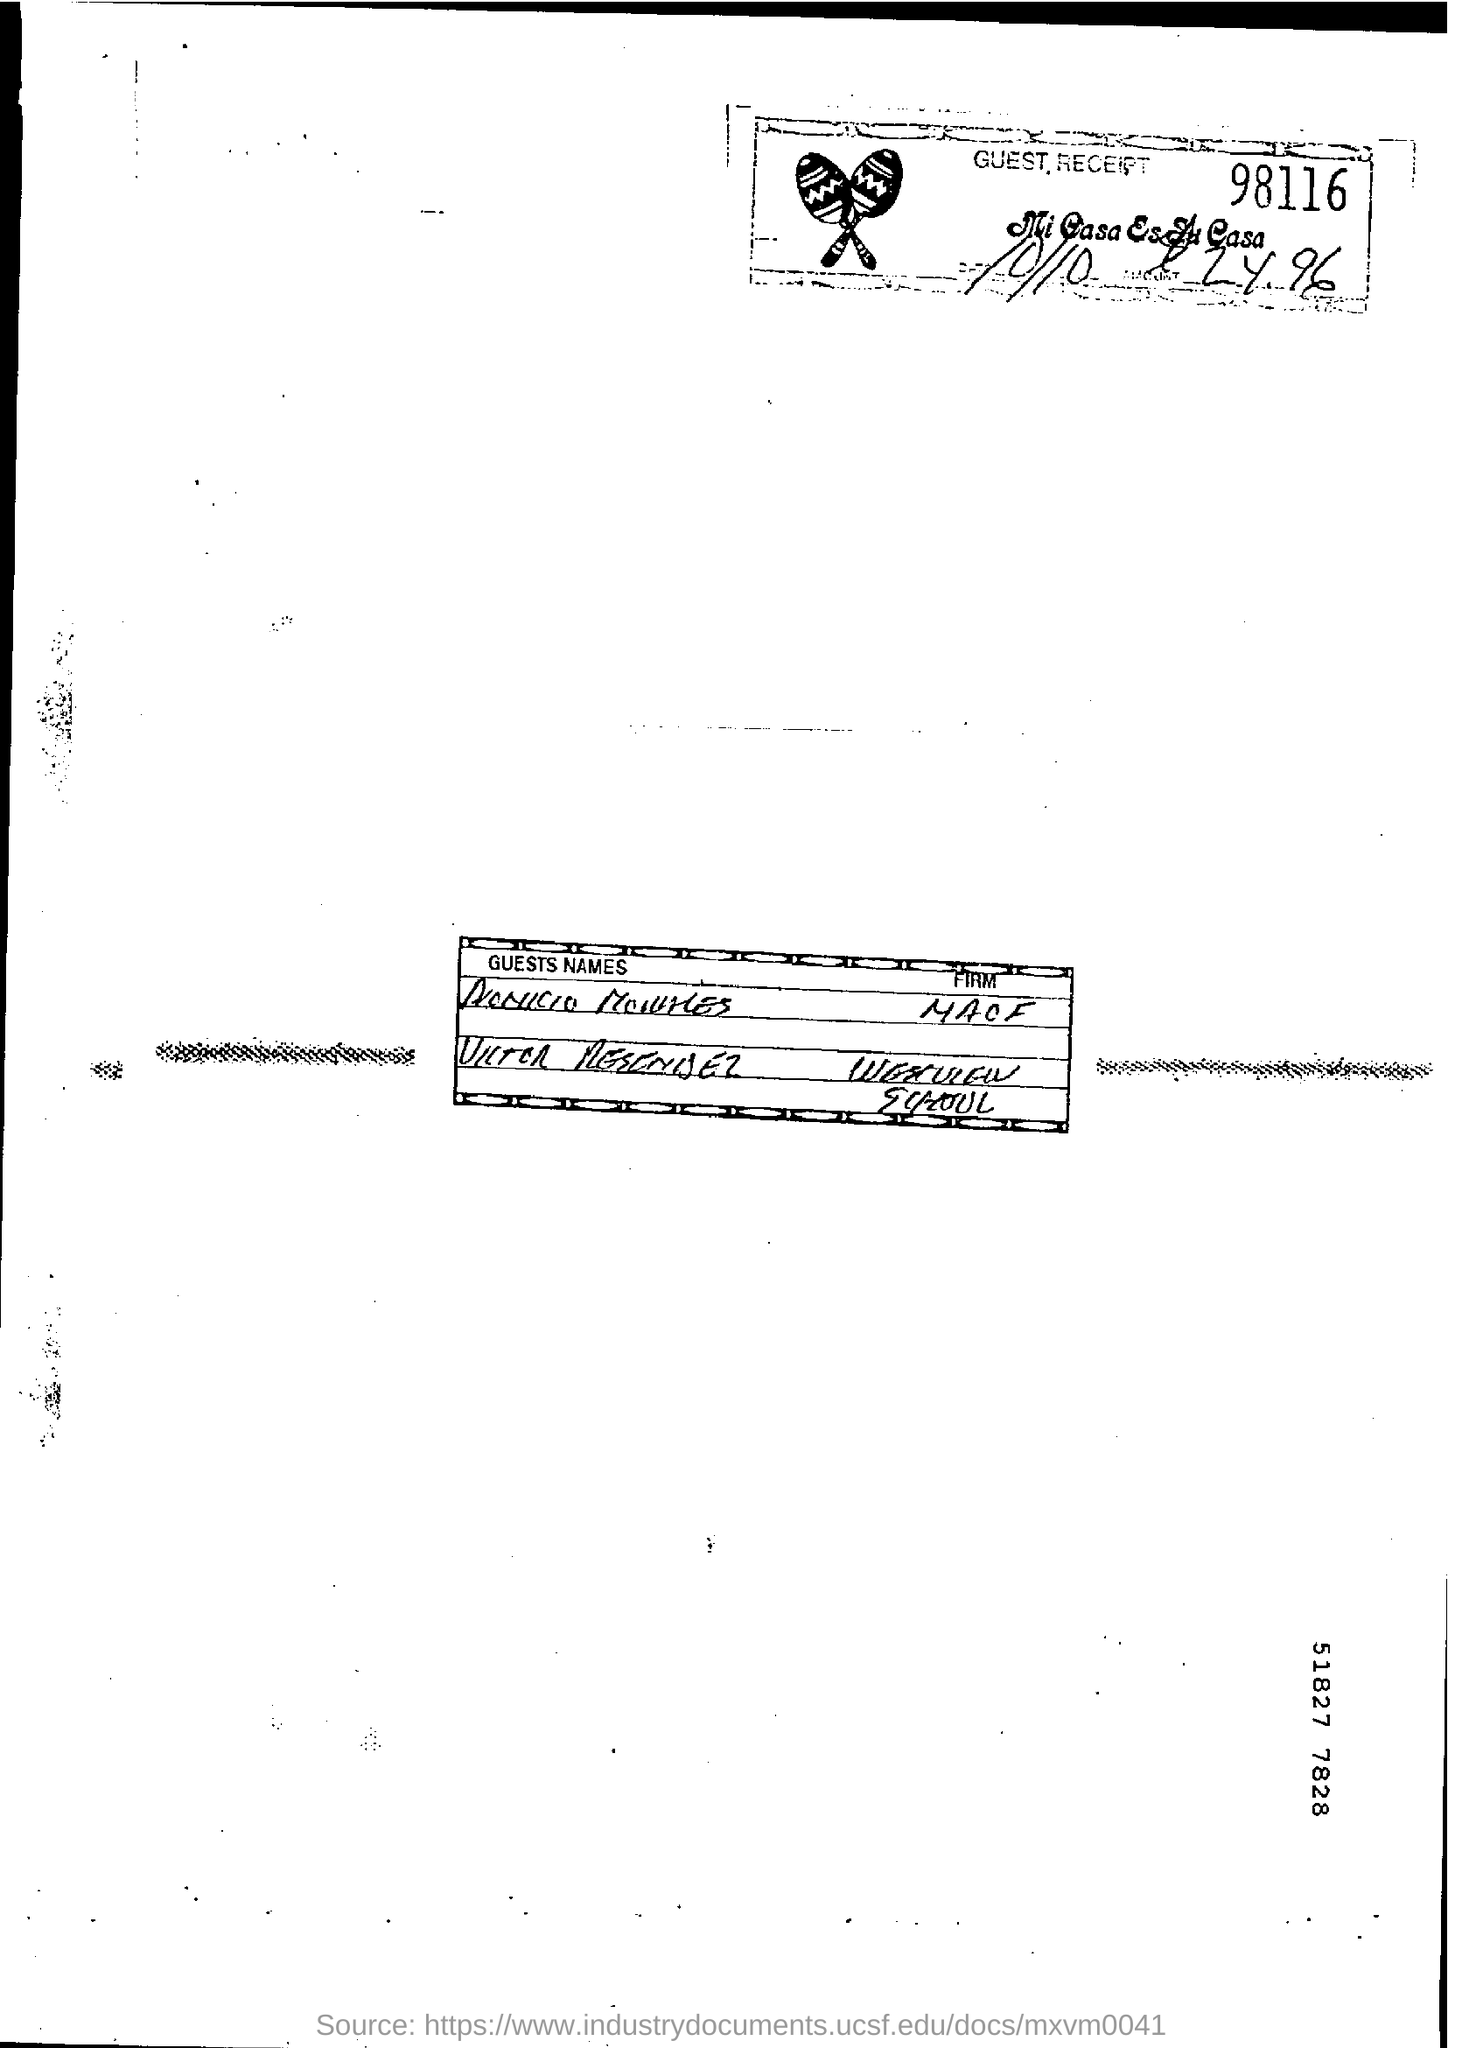Give some essential details in this illustration. The guest reception number in the document is 98116. 